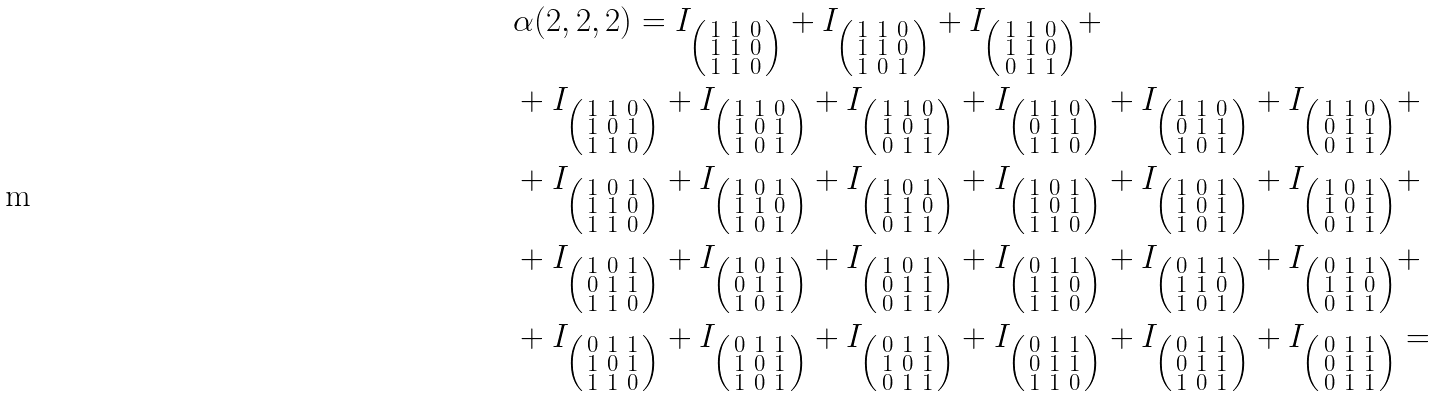<formula> <loc_0><loc_0><loc_500><loc_500>& \alpha ( 2 , 2 , 2 ) = I _ { \left ( \begin{smallmatrix} 1 & 1 & 0 \\ 1 & 1 & 0 \\ 1 & 1 & 0 \end{smallmatrix} \right ) } + I _ { \left ( \begin{smallmatrix} 1 & 1 & 0 \\ 1 & 1 & 0 \\ 1 & 0 & 1 \end{smallmatrix} \right ) } + I _ { \left ( \begin{smallmatrix} 1 & 1 & 0 \\ 1 & 1 & 0 \\ 0 & 1 & 1 \end{smallmatrix} \right ) } + \\ & + I _ { \left ( \begin{smallmatrix} 1 & 1 & 0 \\ 1 & 0 & 1 \\ 1 & 1 & 0 \end{smallmatrix} \right ) } + I _ { \left ( \begin{smallmatrix} 1 & 1 & 0 \\ 1 & 0 & 1 \\ 1 & 0 & 1 \end{smallmatrix} \right ) } + I _ { \left ( \begin{smallmatrix} 1 & 1 & 0 \\ 1 & 0 & 1 \\ 0 & 1 & 1 \end{smallmatrix} \right ) } + I _ { \left ( \begin{smallmatrix} 1 & 1 & 0 \\ 0 & 1 & 1 \\ 1 & 1 & 0 \end{smallmatrix} \right ) } + I _ { \left ( \begin{smallmatrix} 1 & 1 & 0 \\ 0 & 1 & 1 \\ 1 & 0 & 1 \end{smallmatrix} \right ) } + I _ { \left ( \begin{smallmatrix} 1 & 1 & 0 \\ 0 & 1 & 1 \\ 0 & 1 & 1 \end{smallmatrix} \right ) } + \\ & + I _ { \left ( \begin{smallmatrix} 1 & 0 & 1 \\ 1 & 1 & 0 \\ 1 & 1 & 0 \end{smallmatrix} \right ) } + I _ { \left ( \begin{smallmatrix} 1 & 0 & 1 \\ 1 & 1 & 0 \\ 1 & 0 & 1 \end{smallmatrix} \right ) } + I _ { \left ( \begin{smallmatrix} 1 & 0 & 1 \\ 1 & 1 & 0 \\ 0 & 1 & 1 \end{smallmatrix} \right ) } + I _ { \left ( \begin{smallmatrix} 1 & 0 & 1 \\ 1 & 0 & 1 \\ 1 & 1 & 0 \end{smallmatrix} \right ) } + I _ { \left ( \begin{smallmatrix} 1 & 0 & 1 \\ 1 & 0 & 1 \\ 1 & 0 & 1 \end{smallmatrix} \right ) } + I _ { \left ( \begin{smallmatrix} 1 & 0 & 1 \\ 1 & 0 & 1 \\ 0 & 1 & 1 \end{smallmatrix} \right ) } + \\ & + I _ { \left ( \begin{smallmatrix} 1 & 0 & 1 \\ 0 & 1 & 1 \\ 1 & 1 & 0 \end{smallmatrix} \right ) } + I _ { \left ( \begin{smallmatrix} 1 & 0 & 1 \\ 0 & 1 & 1 \\ 1 & 0 & 1 \end{smallmatrix} \right ) } + I _ { \left ( \begin{smallmatrix} 1 & 0 & 1 \\ 0 & 1 & 1 \\ 0 & 1 & 1 \end{smallmatrix} \right ) } + I _ { \left ( \begin{smallmatrix} 0 & 1 & 1 \\ 1 & 1 & 0 \\ 1 & 1 & 0 \end{smallmatrix} \right ) } + I _ { \left ( \begin{smallmatrix} 0 & 1 & 1 \\ 1 & 1 & 0 \\ 1 & 0 & 1 \end{smallmatrix} \right ) } + I _ { \left ( \begin{smallmatrix} 0 & 1 & 1 \\ 1 & 1 & 0 \\ 0 & 1 & 1 \end{smallmatrix} \right ) } + \\ & + I _ { \left ( \begin{smallmatrix} 0 & 1 & 1 \\ 1 & 0 & 1 \\ 1 & 1 & 0 \end{smallmatrix} \right ) } + I _ { \left ( \begin{smallmatrix} 0 & 1 & 1 \\ 1 & 0 & 1 \\ 1 & 0 & 1 \end{smallmatrix} \right ) } + I _ { \left ( \begin{smallmatrix} 0 & 1 & 1 \\ 1 & 0 & 1 \\ 0 & 1 & 1 \end{smallmatrix} \right ) } + I _ { \left ( \begin{smallmatrix} 0 & 1 & 1 \\ 0 & 1 & 1 \\ 1 & 1 & 0 \end{smallmatrix} \right ) } + I _ { \left ( \begin{smallmatrix} 0 & 1 & 1 \\ 0 & 1 & 1 \\ 1 & 0 & 1 \end{smallmatrix} \right ) } + I _ { \left ( \begin{smallmatrix} 0 & 1 & 1 \\ 0 & 1 & 1 \\ 0 & 1 & 1 \end{smallmatrix} \right ) } =</formula> 